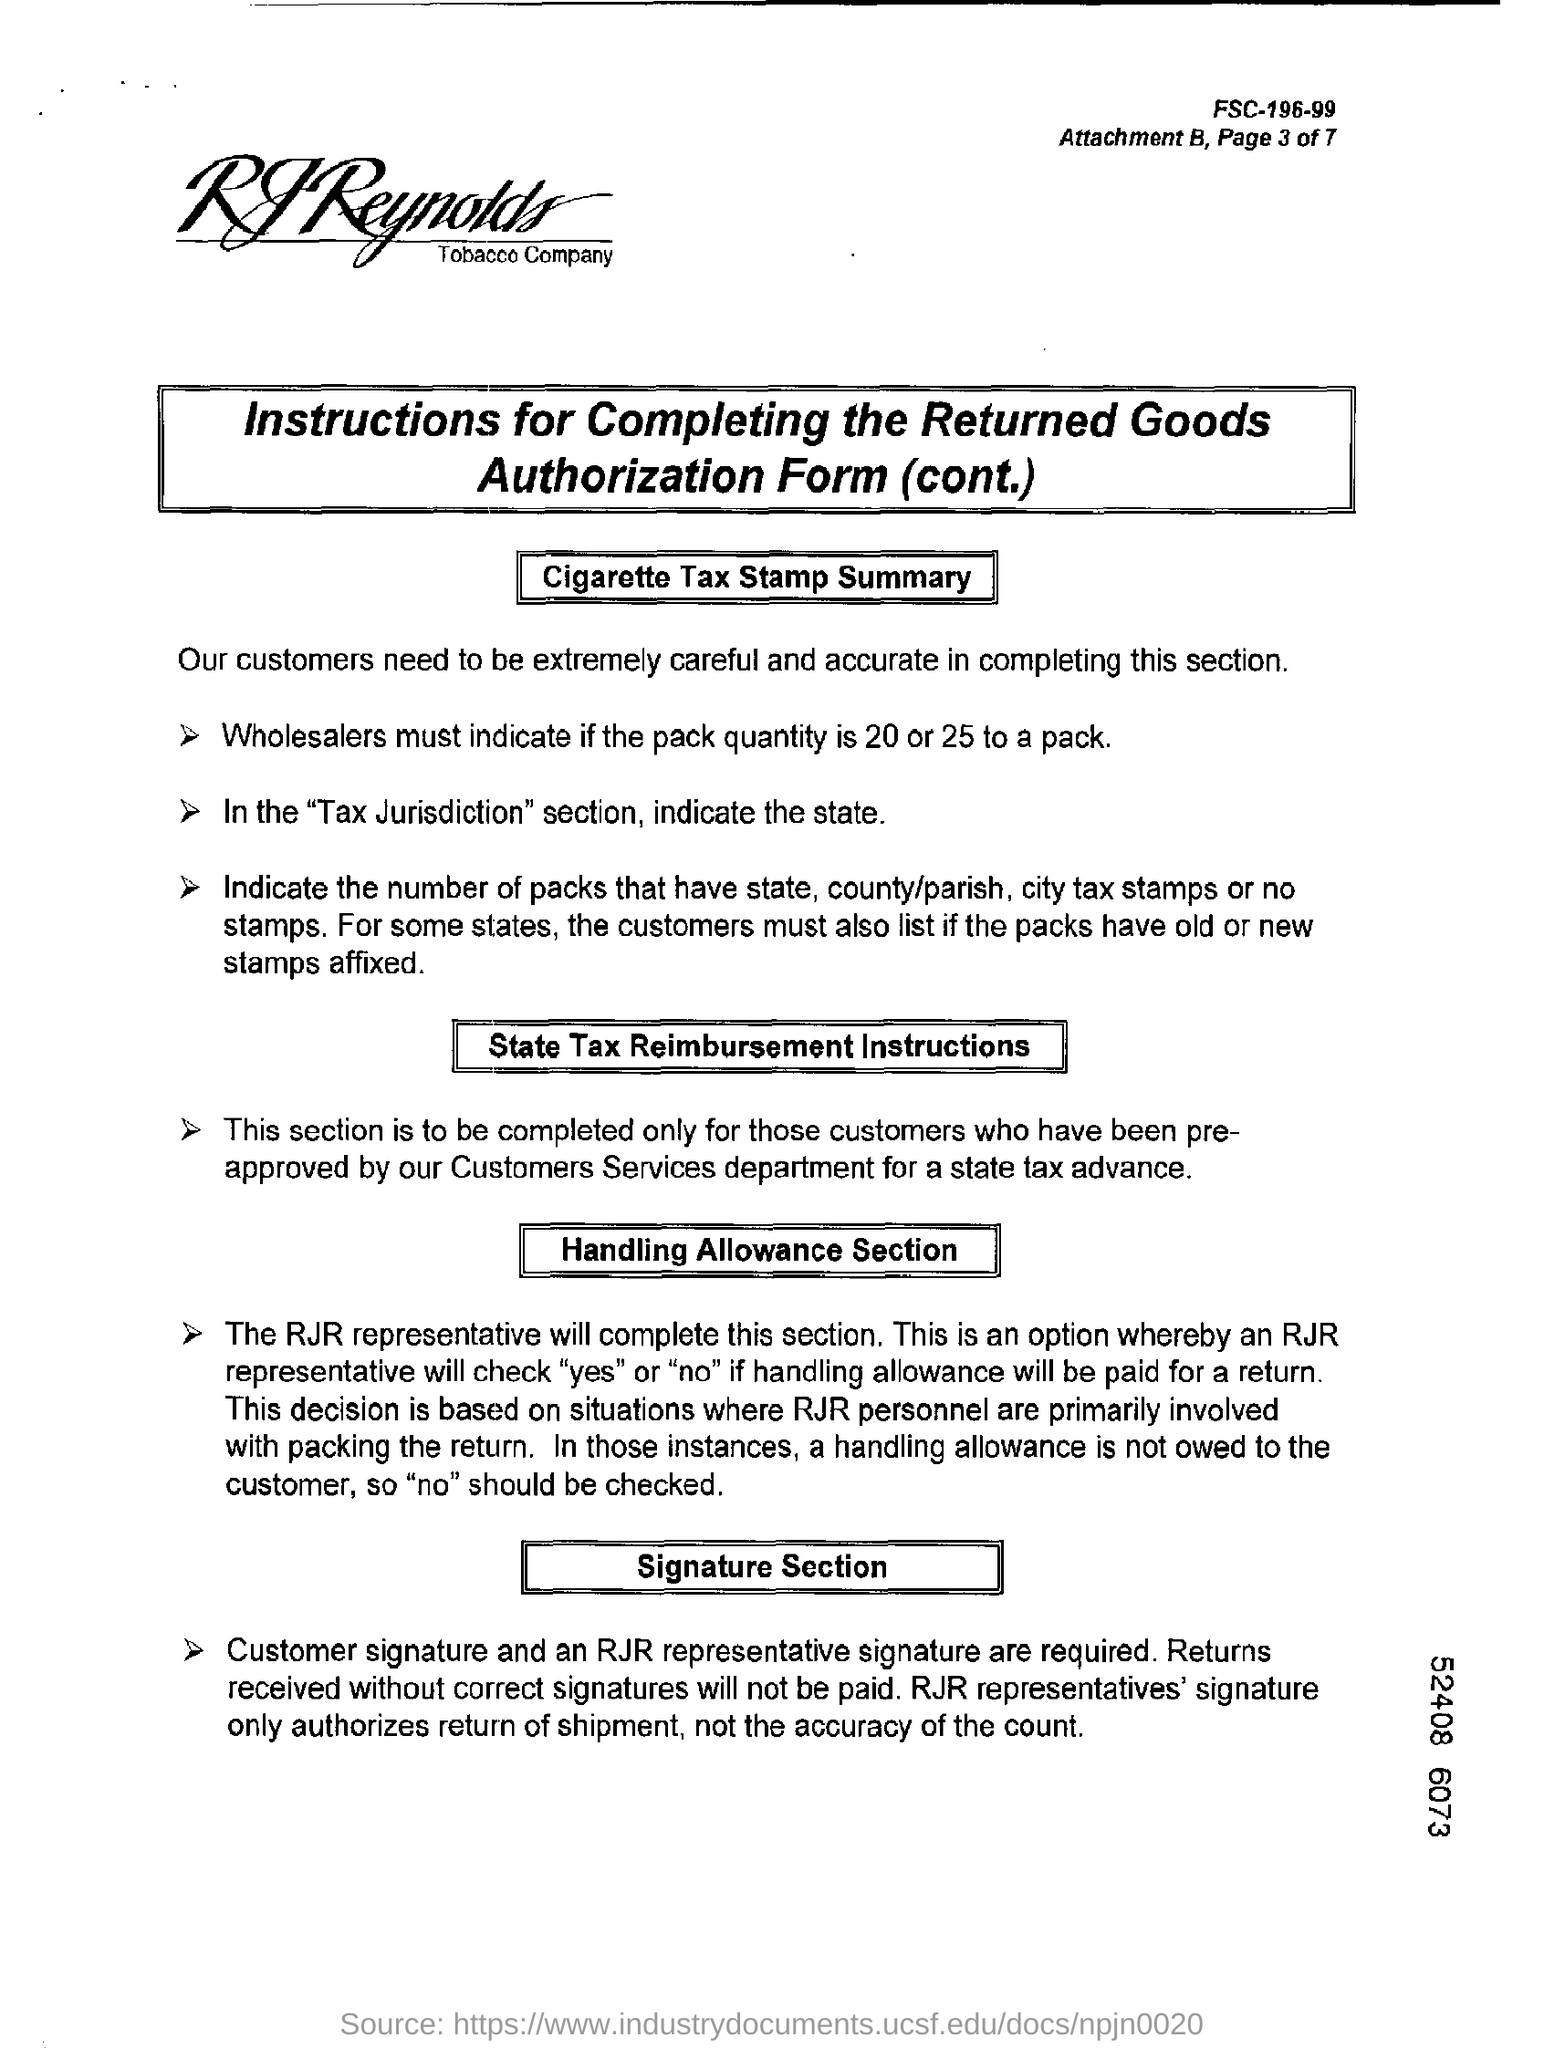In which section should you indicate the state?
Your answer should be very brief. "Tax Jurisdiction". Who will complete Handling Allowance Section?
Make the answer very short. The RJR representative. Whose signatures are required in the signature section?
Your answer should be compact. Customer signature and an RJR representative signature. What does RJR Representatives' signature authorize?
Your answer should be very brief. Only authorizes return of shipment, not the accuracy of the count. 